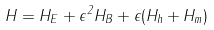Convert formula to latex. <formula><loc_0><loc_0><loc_500><loc_500>H = H _ { E } + \epsilon ^ { 2 } H _ { B } + \epsilon ( H _ { h } + H _ { m } )</formula> 